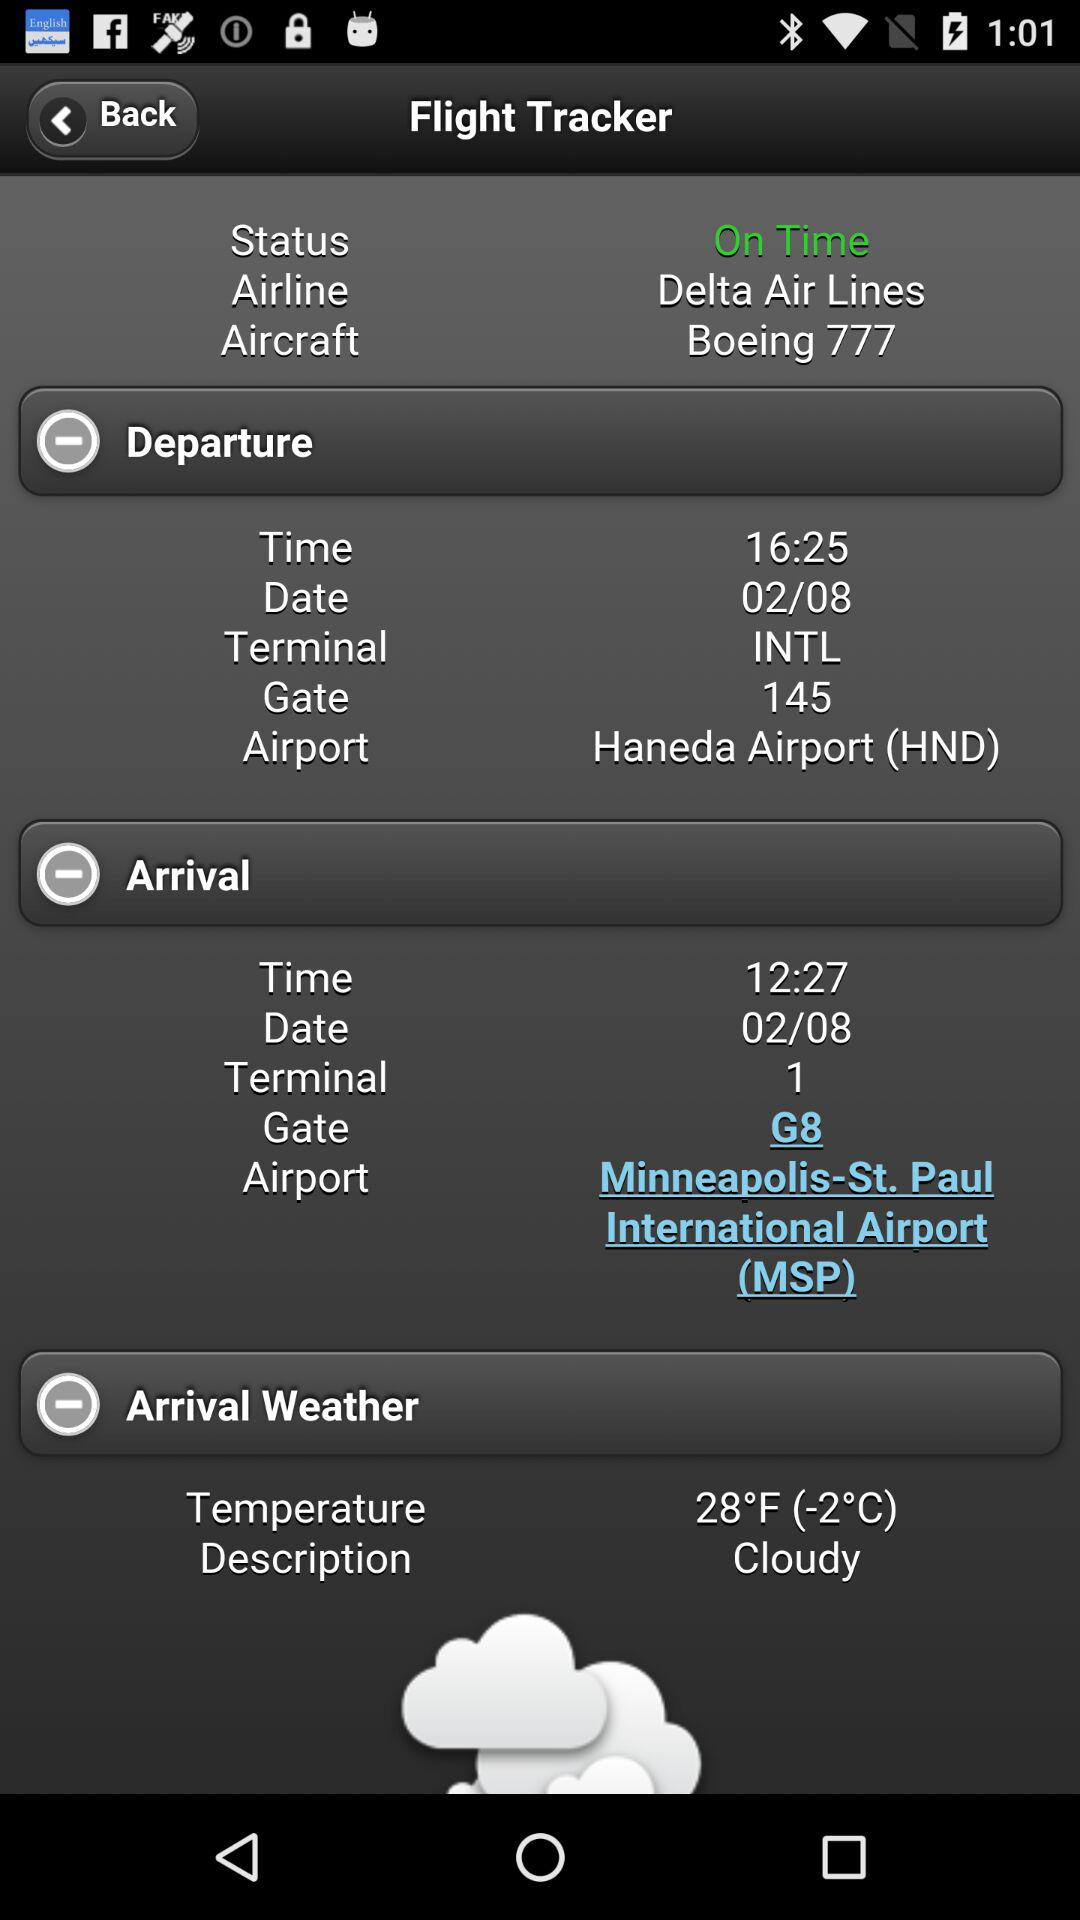What is the departure airport's name? The departure airport's name is Haneda Airport (HND). 